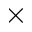<formula> <loc_0><loc_0><loc_500><loc_500>\times</formula> 